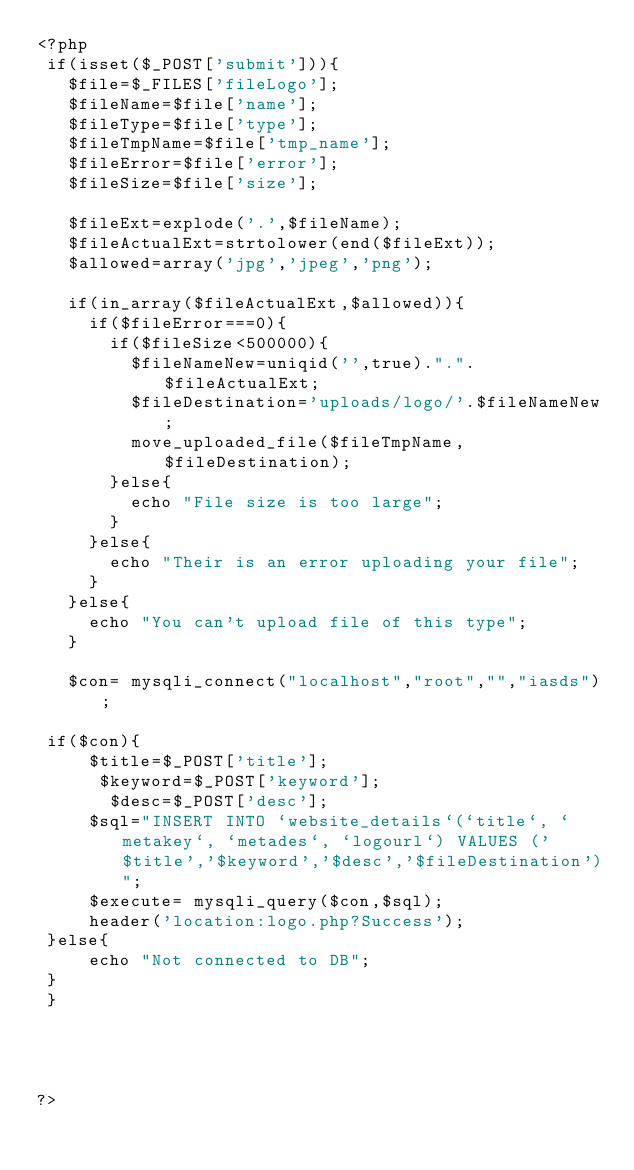Convert code to text. <code><loc_0><loc_0><loc_500><loc_500><_PHP_><?php
 if(isset($_POST['submit'])){
   $file=$_FILES['fileLogo'];  
   $fileName=$file['name'];
   $fileType=$file['type'];
   $fileTmpName=$file['tmp_name'];
   $fileError=$file['error'];
   $fileSize=$file['size'];

   $fileExt=explode('.',$fileName);
   $fileActualExt=strtolower(end($fileExt));
   $allowed=array('jpg','jpeg','png');

   if(in_array($fileActualExt,$allowed)){
     if($fileError===0){
       if($fileSize<500000){
         $fileNameNew=uniqid('',true).".".$fileActualExt;
         $fileDestination='uploads/logo/'.$fileNameNew;
         move_uploaded_file($fileTmpName,$fileDestination);         
       }else{
         echo "File size is too large";
       }
     }else{
       echo "Their is an error uploading your file";
     }
   }else{
     echo "You can't upload file of this type";
   }
   
   $con= mysqli_connect("localhost","root","","iasds");
 
 if($con){
     $title=$_POST['title']; 
      $keyword=$_POST['keyword'];
       $desc=$_POST['desc'];
     $sql="INSERT INTO `website_details`(`title`, `metakey`, `metades`, `logourl`) VALUES ('$title','$keyword','$desc','$fileDestination')";
     $execute= mysqli_query($con,$sql);
     header('location:logo.php?Success');
 }else{
     echo "Not connected to DB";
 }
 }
  
 
 
 
?>

</code> 